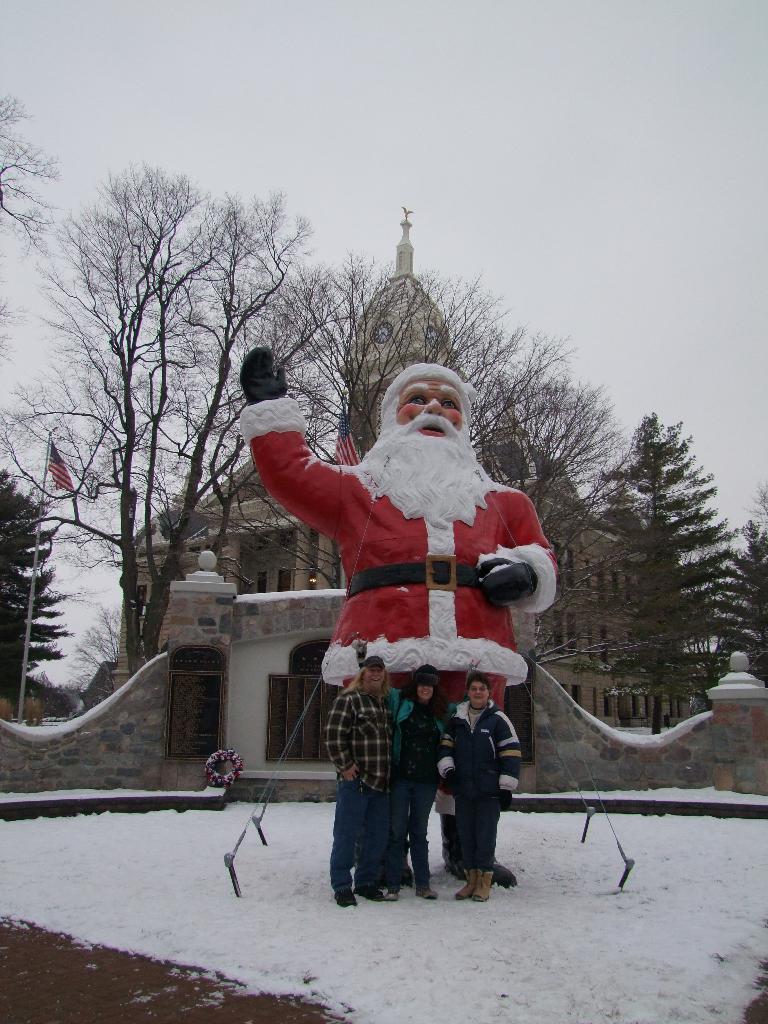Please provide a concise description of this image. In the picture we can see a snow surface and a Santa Claus sculpture placed on it and some people are standing near it and in the background, we can see a wall with a door and flag with a pole and behind it, we can see a historical building with a clock tower on it and around the building we can see many trees and a sky behind the building. 